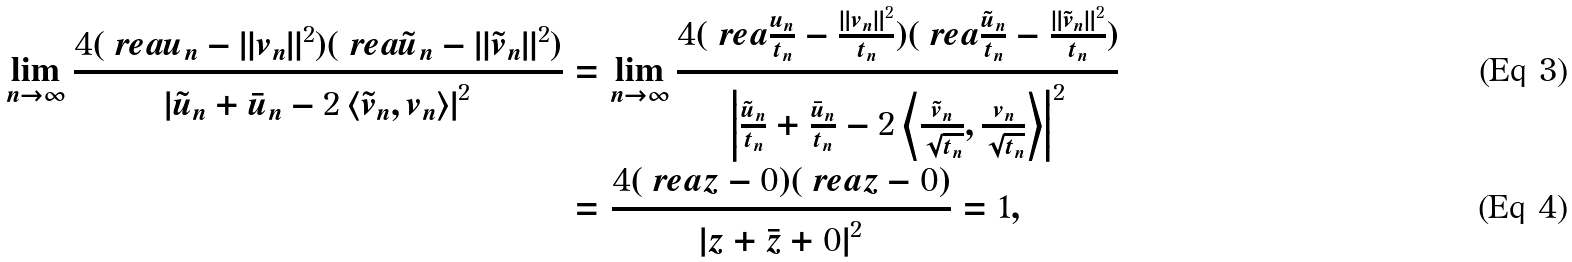Convert formula to latex. <formula><loc_0><loc_0><loc_500><loc_500>\lim _ { n \to \infty } \frac { 4 ( \ r e a u _ { n } - \| v _ { n } \| ^ { 2 } ) ( \ r e a \tilde { u } _ { n } - \| \tilde { v } _ { n } \| ^ { 2 } ) } { \left | \tilde { u } _ { n } + \bar { u } _ { n } - 2 \left \langle \tilde { v } _ { n } , v _ { n } \right \rangle \right | ^ { 2 } } & = \lim _ { n \to \infty } \frac { 4 ( \ r e a \frac { u _ { n } } { t _ { n } } - \frac { \| v _ { n } \| ^ { 2 } } { t _ { n } } ) ( \ r e a \frac { \tilde { u } _ { n } } { t _ { n } } - \frac { \| \tilde { v } _ { n } \| ^ { 2 } } { t _ { n } } ) } { \left | \frac { \tilde { u } _ { n } } { t _ { n } } + \frac { \bar { u } _ { n } } { t _ { n } } - 2 \left \langle \frac { \tilde { v } _ { n } } { \sqrt { t _ { n } } } , \frac { v _ { n } } { \sqrt { t _ { n } } } \right \rangle \right | ^ { 2 } } \\ & = \frac { 4 ( \ r e a z - 0 ) ( \ r e a z - 0 ) } { \left | z + \bar { z } + 0 \right | ^ { 2 } } = 1 ,</formula> 